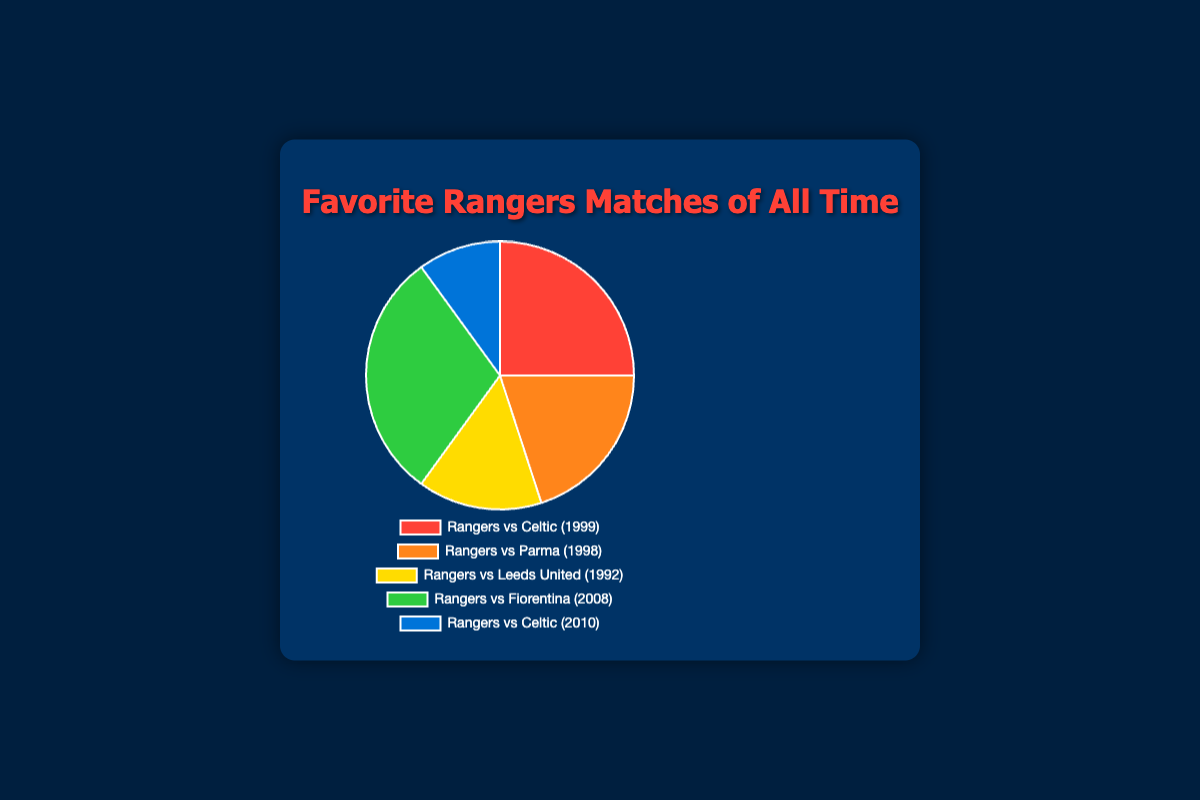Which match has the highest win rate? The pie chart shows that "Rangers vs Fiorentina (2008)" has the largest slice, indicated by 30% win rate, which is higher than the win rates of the other matches.
Answer: Rangers vs Fiorentina (2008) How many matches from the 1990s era are included? The pie chart indicates three matches from the 1990s era: "Rangers vs Celtic (1999)", "Rangers vs Parma (1998)", and "Rangers vs Leeds United (1992)".
Answer: Three What is the combined win rate of matches in the 1990s era? Summing up the win rates of the three 1990s matches: Rangers vs Celtic (1999) - 25%, Rangers vs Parma (1998) - 20%, and Rangers vs Leeds United (1992) - 15%. The combined win rate is 25% + 20% + 15% = 60%.
Answer: 60% Which match is represented by the smallest slice of the pie chart? The pie chart shows that "Rangers vs Celtic (2010)" has the smallest slice with a win rate of 10%.
Answer: Rangers vs Celtic (2010) Compare the win rate of "Rangers vs Fiorentina (2008)" to "Rangers vs Celtic (1999)". The win rate for "Rangers vs Fiorentina (2008)" is 30%, whereas for "Rangers vs Celtic (1999)" it is 25%. Therefore, "Rangers vs Fiorentina (2008)" has a higher win rate.
Answer: Rangers vs Fiorentina (2008) Which match has a 20% win rate and what era is it from? The pie chart indicates that "Rangers vs Parma (1998)" has a 20% win rate. This match is from the 1990s era.
Answer: Rangers vs Parma (1998), 1990s What is the difference in win rate between the matches with the highest and lowest win rates? The match with the highest win rate is "Rangers vs Fiorentina (2008)" at 30%, and the lowest is "Rangers vs Celtic (2010)" at 10%. The difference is 30% - 10% = 20%.
Answer: 20% What colors represent the matches "Rangers vs Parma (1998)" and "Rangers vs Leeds United (1992)" in the pie chart? According to the pie chart, "Rangers vs Parma (1998)" is shown in orange and "Rangers vs Leeds United (1992)" is shown in yellow.
Answer: Orange, Yellow 